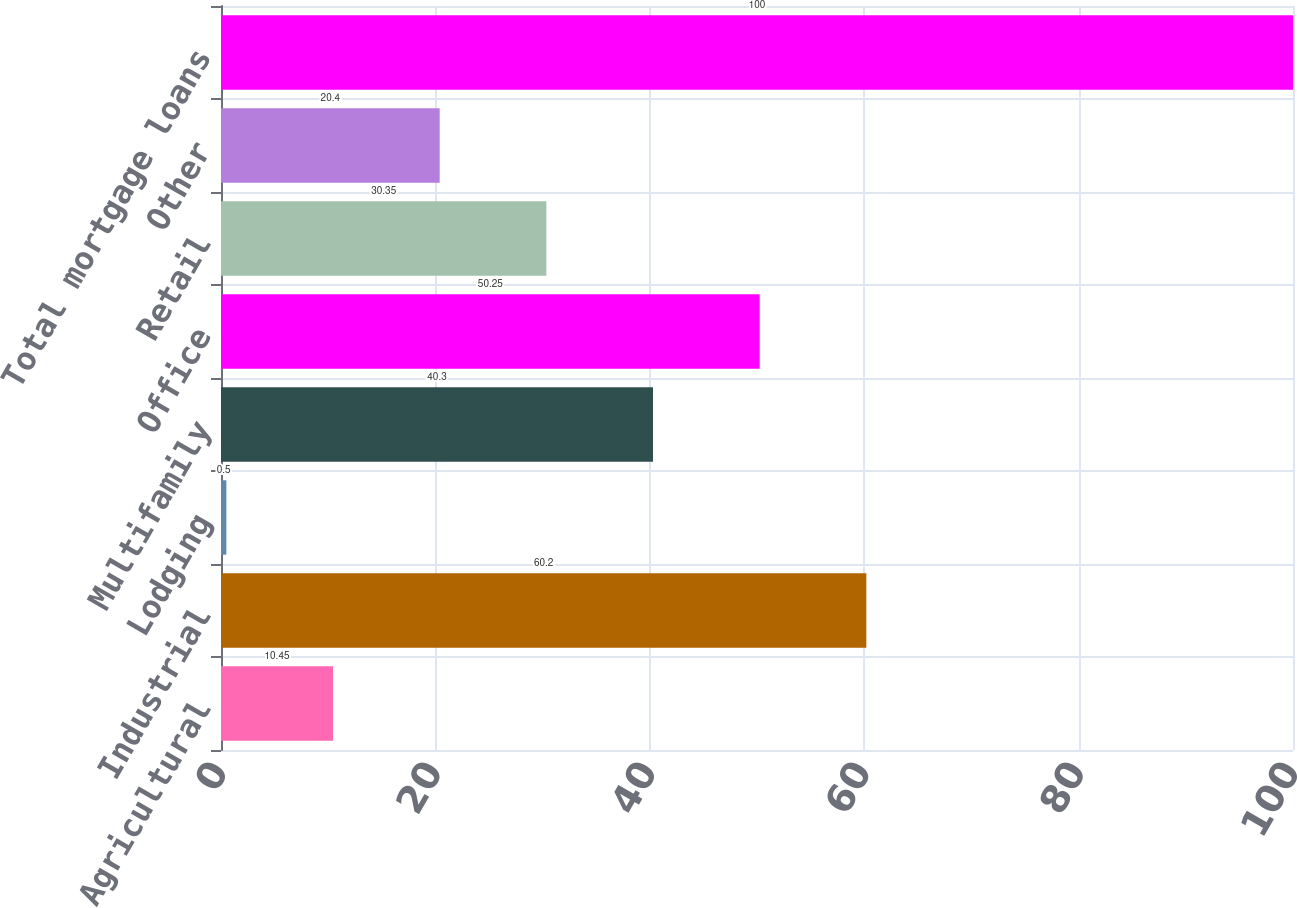Convert chart to OTSL. <chart><loc_0><loc_0><loc_500><loc_500><bar_chart><fcel>Agricultural<fcel>Industrial<fcel>Lodging<fcel>Multifamily<fcel>Office<fcel>Retail<fcel>Other<fcel>Total mortgage loans<nl><fcel>10.45<fcel>60.2<fcel>0.5<fcel>40.3<fcel>50.25<fcel>30.35<fcel>20.4<fcel>100<nl></chart> 